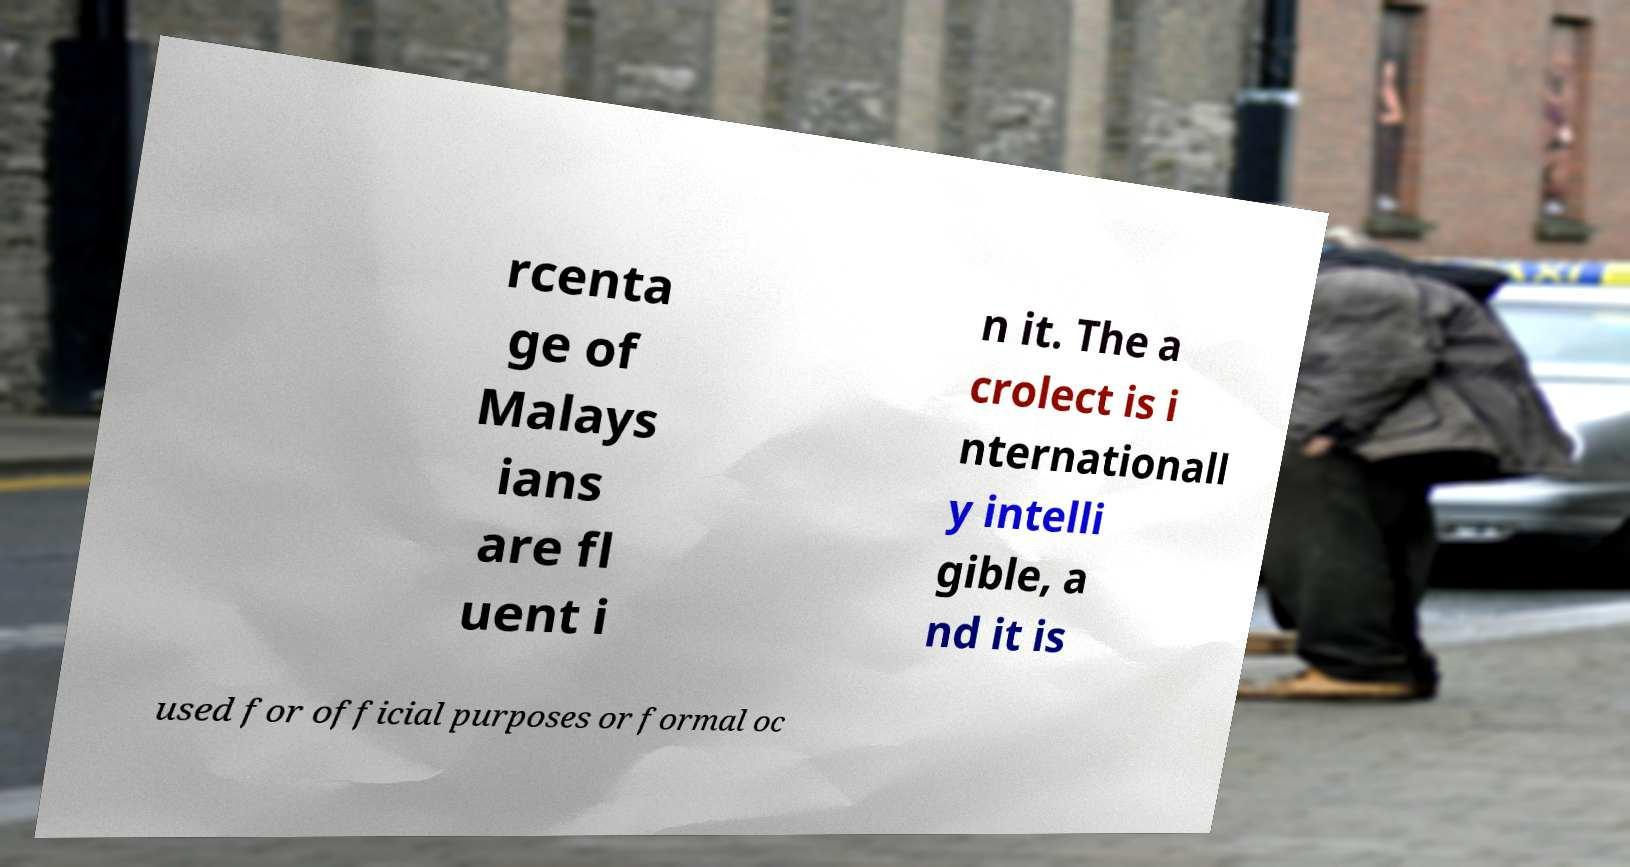Could you assist in decoding the text presented in this image and type it out clearly? rcenta ge of Malays ians are fl uent i n it. The a crolect is i nternationall y intelli gible, a nd it is used for official purposes or formal oc 